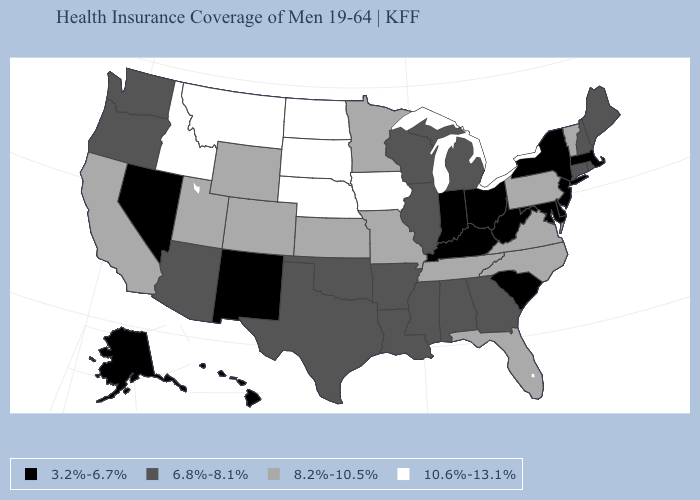Name the states that have a value in the range 6.8%-8.1%?
Concise answer only. Alabama, Arizona, Arkansas, Connecticut, Georgia, Illinois, Louisiana, Maine, Michigan, Mississippi, New Hampshire, Oklahoma, Oregon, Rhode Island, Texas, Washington, Wisconsin. Does North Carolina have the highest value in the South?
Write a very short answer. Yes. What is the lowest value in the USA?
Be succinct. 3.2%-6.7%. Does the map have missing data?
Keep it brief. No. Which states have the lowest value in the West?
Give a very brief answer. Alaska, Hawaii, Nevada, New Mexico. Name the states that have a value in the range 3.2%-6.7%?
Concise answer only. Alaska, Delaware, Hawaii, Indiana, Kentucky, Maryland, Massachusetts, Nevada, New Jersey, New Mexico, New York, Ohio, South Carolina, West Virginia. Name the states that have a value in the range 6.8%-8.1%?
Answer briefly. Alabama, Arizona, Arkansas, Connecticut, Georgia, Illinois, Louisiana, Maine, Michigan, Mississippi, New Hampshire, Oklahoma, Oregon, Rhode Island, Texas, Washington, Wisconsin. Is the legend a continuous bar?
Answer briefly. No. Among the states that border Maryland , does Delaware have the lowest value?
Answer briefly. Yes. What is the lowest value in the West?
Give a very brief answer. 3.2%-6.7%. Does Florida have the highest value in the USA?
Answer briefly. No. Name the states that have a value in the range 3.2%-6.7%?
Keep it brief. Alaska, Delaware, Hawaii, Indiana, Kentucky, Maryland, Massachusetts, Nevada, New Jersey, New Mexico, New York, Ohio, South Carolina, West Virginia. Name the states that have a value in the range 10.6%-13.1%?
Quick response, please. Idaho, Iowa, Montana, Nebraska, North Dakota, South Dakota. Does Tennessee have a higher value than Oklahoma?
Short answer required. Yes. Does the first symbol in the legend represent the smallest category?
Keep it brief. Yes. 